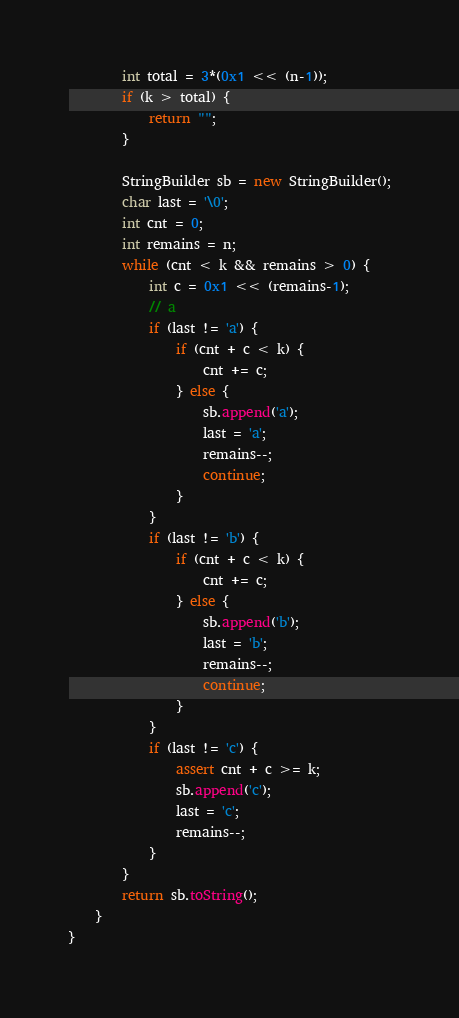Convert code to text. <code><loc_0><loc_0><loc_500><loc_500><_Java_>        int total = 3*(0x1 << (n-1));
        if (k > total) {
            return "";
        }

        StringBuilder sb = new StringBuilder();
        char last = '\0';
        int cnt = 0;
        int remains = n;
        while (cnt < k && remains > 0) {
            int c = 0x1 << (remains-1);
            // a
            if (last != 'a') {
                if (cnt + c < k) {
                    cnt += c;
                } else {
                    sb.append('a');
                    last = 'a';
                    remains--;
                    continue;
                }
            }
            if (last != 'b') {
                if (cnt + c < k) {
                    cnt += c;
                } else {
                    sb.append('b');
                    last = 'b';
                    remains--;
                    continue;
                }
            }
            if (last != 'c') {
                assert cnt + c >= k;
                sb.append('c');
                last = 'c';
                remains--;
            }
        }
        return sb.toString();
    }
}
</code> 